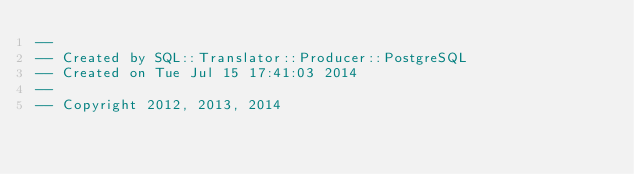Convert code to text. <code><loc_0><loc_0><loc_500><loc_500><_SQL_>-- 
-- Created by SQL::Translator::Producer::PostgreSQL
-- Created on Tue Jul 15 17:41:03 2014
-- 
-- Copyright 2012, 2013, 2014</code> 